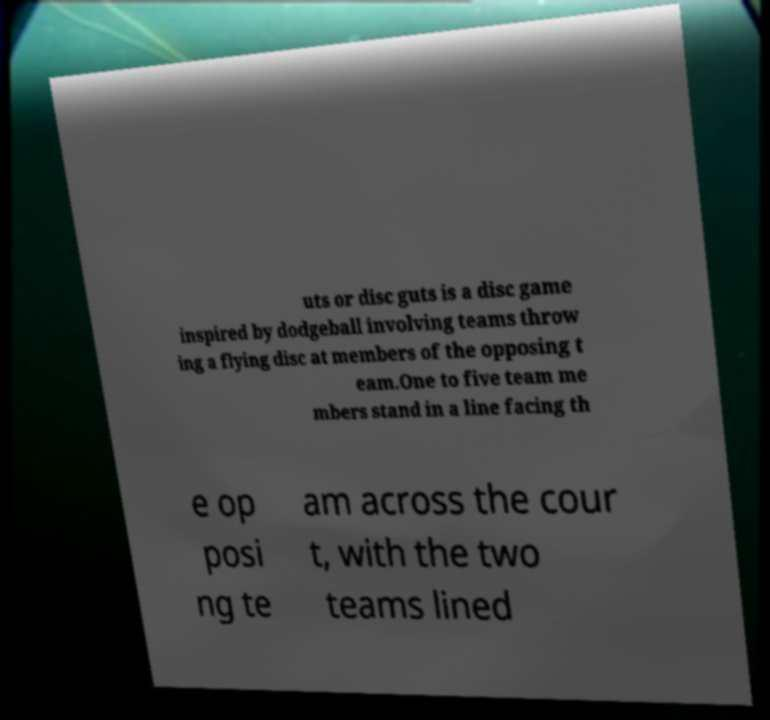Could you extract and type out the text from this image? uts or disc guts is a disc game inspired by dodgeball involving teams throw ing a flying disc at members of the opposing t eam.One to five team me mbers stand in a line facing th e op posi ng te am across the cour t, with the two teams lined 